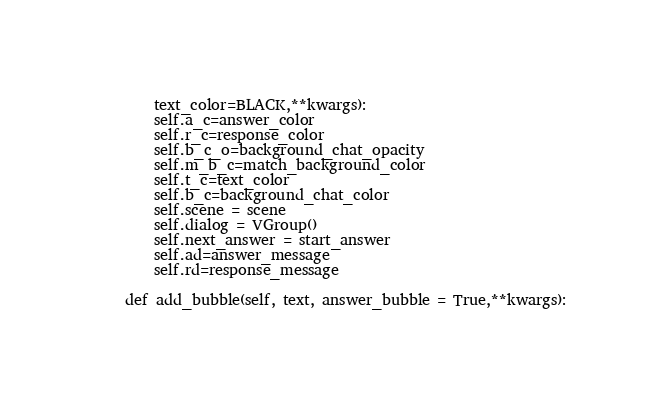Convert code to text. <code><loc_0><loc_0><loc_500><loc_500><_Python_>		text_color=BLACK,**kwargs):
		self.a_c=answer_color
		self.r_c=response_color
		self.b_c_o=background_chat_opacity
		self.m_b_c=match_background_color
		self.t_c=text_color
		self.b_c=background_chat_color
		self.scene = scene
		self.dialog = VGroup()
		self.next_answer = start_answer
		self.ad=answer_message
		self.rd=response_message

	def add_bubble(self, text, answer_bubble = True,**kwargs):</code> 